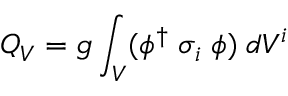Convert formula to latex. <formula><loc_0><loc_0><loc_500><loc_500>Q _ { V } = g \int _ { V } ( \phi ^ { \dagger } \, \sigma _ { i } \, \phi ) \, d V ^ { i }</formula> 